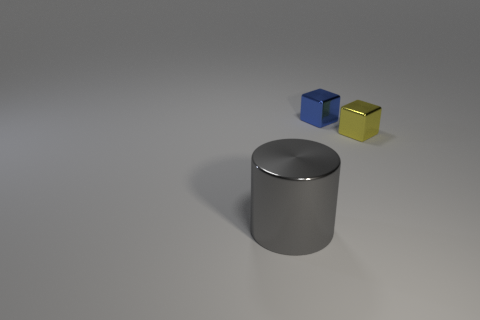Add 2 tiny cylinders. How many objects exist? 5 Subtract all cylinders. How many objects are left? 2 Subtract 0 red balls. How many objects are left? 3 Subtract all blue blocks. Subtract all small yellow shiny objects. How many objects are left? 1 Add 2 cylinders. How many cylinders are left? 3 Add 1 shiny cylinders. How many shiny cylinders exist? 2 